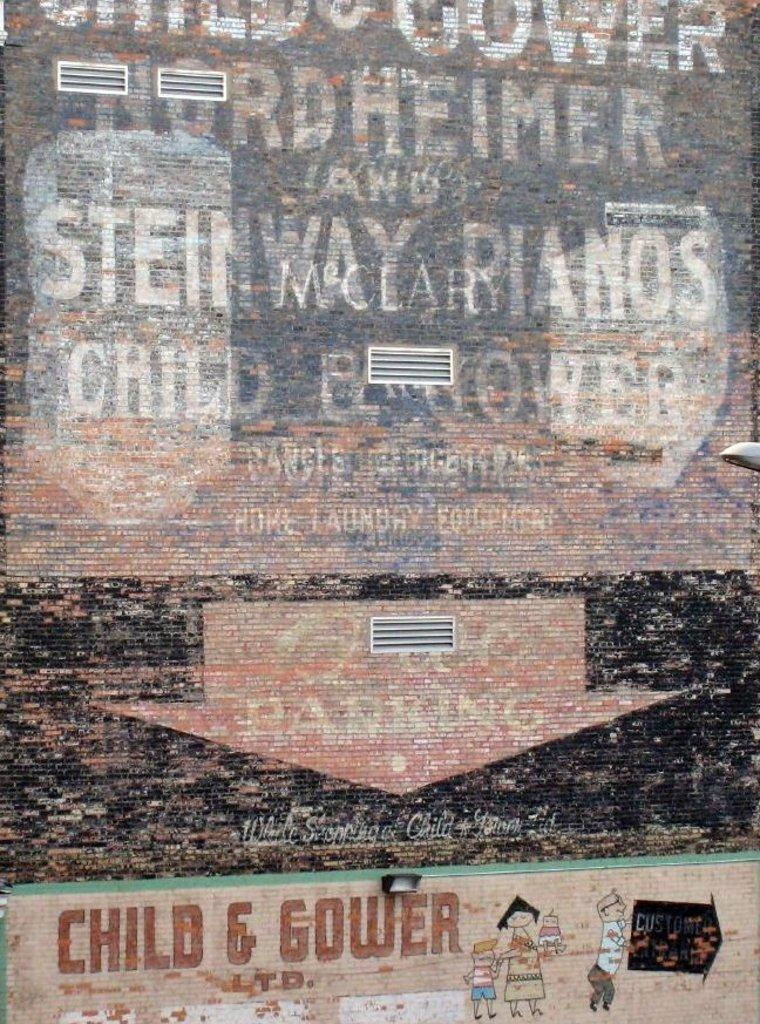<image>
Describe the image concisely. a poster for child and gower with a run down feel 